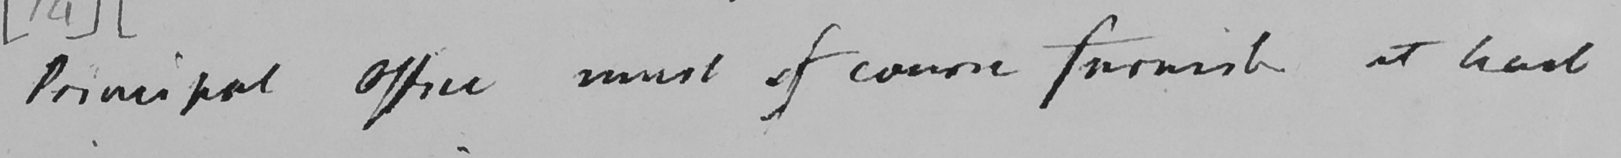What text is written in this handwritten line? Principal Office must of course furnish at least 